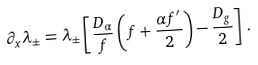<formula> <loc_0><loc_0><loc_500><loc_500>\partial _ { x } \lambda _ { \pm } = \lambda _ { \pm } \left [ \frac { D _ { \alpha } } { f } \left ( f + \frac { \alpha f ^ { \prime } } { 2 } \right ) - \frac { D _ { g } } { 2 } \right ] \, .</formula> 